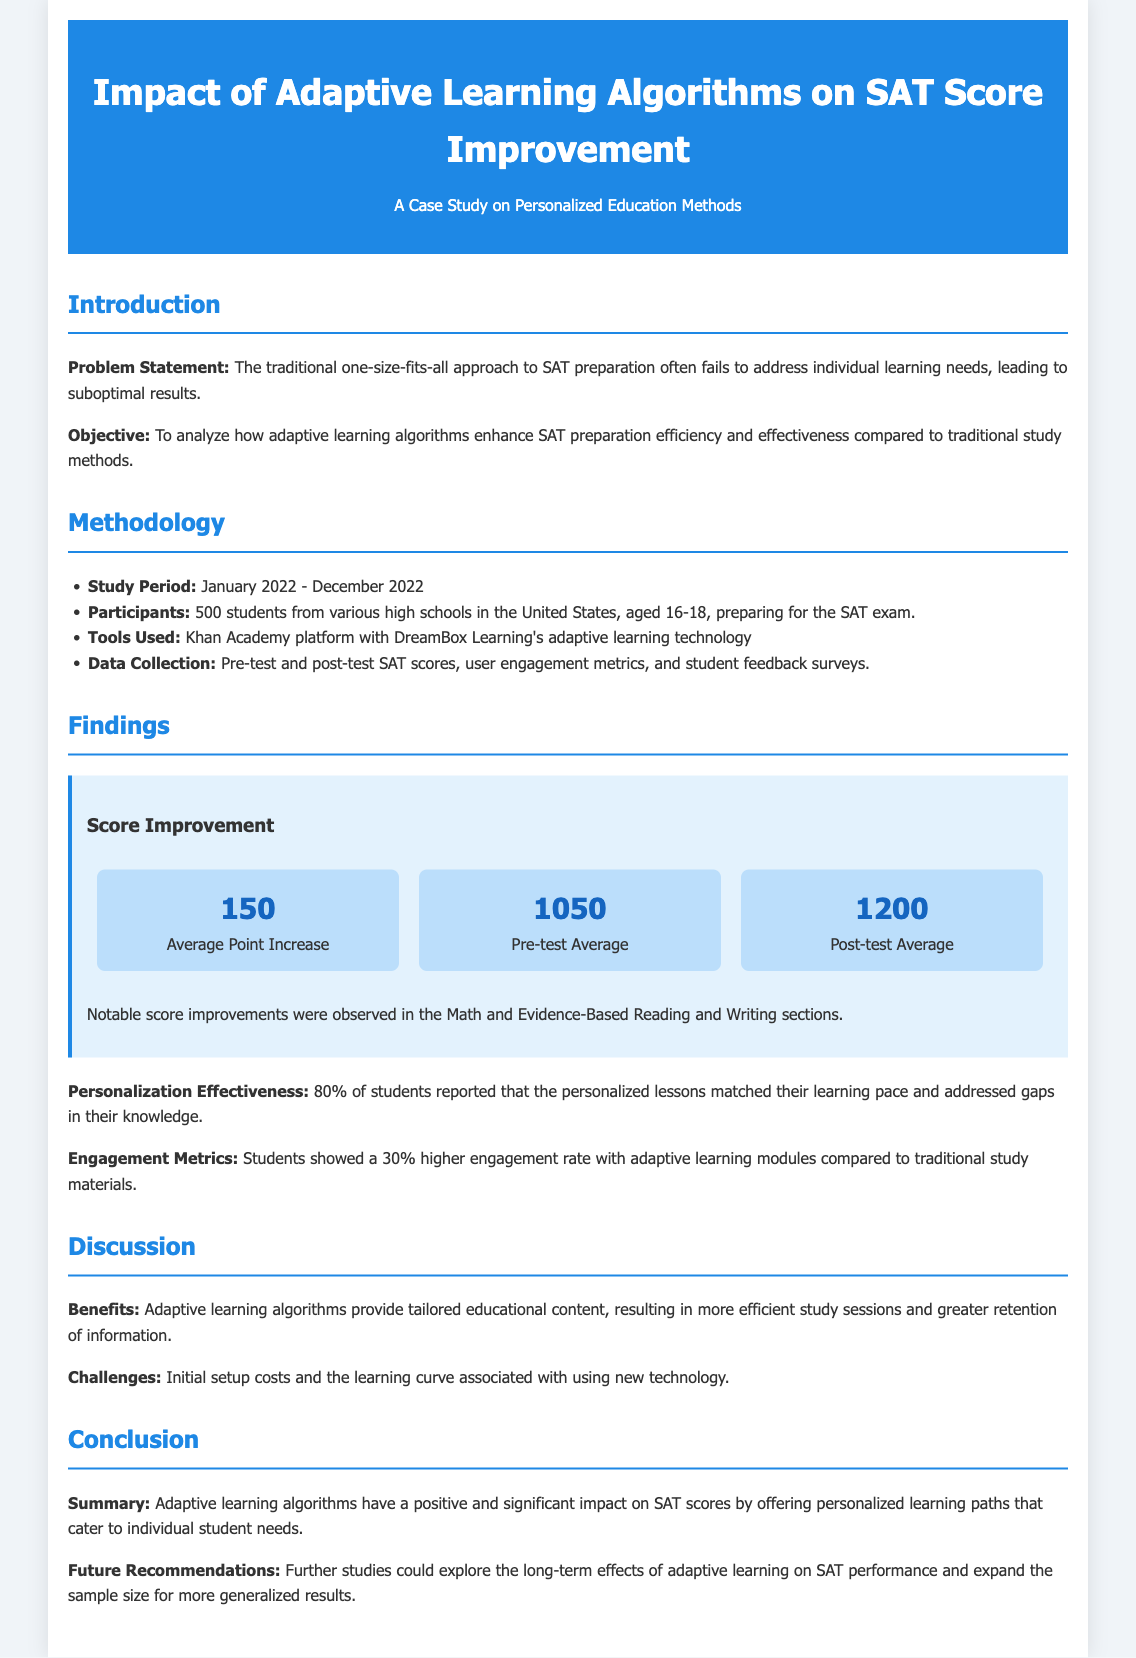What was the study period? The study period is mentioned explicitly in the document as spanning January 2022 to December 2022.
Answer: January 2022 - December 2022 How many students participated in the study? The document lists 500 students as the number of participants in the study.
Answer: 500 What was the average pre-test score? The average pre-test score can be found in the findings section, which states it was 1050.
Answer: 1050 What percentage of students reported effective personalization? The document states that 80% of students reported that personalized lessons were effective.
Answer: 80% What was the average point increase in scores? The document specifies that the average point increase observed was 150.
Answer: 150 What learning platform was used in the study? The document names Khan Academy as the platform used for the adaptive learning study.
Answer: Khan Academy What was the engagement rate increase with adaptive learning? According to the findings, students showed a 30% higher engagement rate with adaptive learning compared to traditional materials.
Answer: 30% What are some challenges mentioned in the discussion? The challenges listed include initial setup costs and a learning curve with new technology.
Answer: Initial setup costs and learning curve What is a key benefit of adaptive learning algorithms? The document highlights that a key benefit is tailored educational content leading to efficient study sessions.
Answer: Tailored educational content 